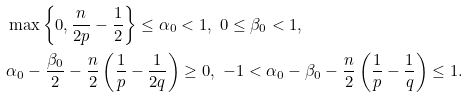Convert formula to latex. <formula><loc_0><loc_0><loc_500><loc_500>& \max \left \{ 0 , \frac { n } { 2 p } - \frac { 1 } { 2 } \right \} \leq \alpha _ { 0 } < 1 , \ 0 \leq \beta _ { 0 } < 1 , \\ & \alpha _ { 0 } - \frac { \beta _ { 0 } } { 2 } - \frac { n } { 2 } \left ( \frac { 1 } { p } - \frac { 1 } { 2 q } \right ) \geq 0 , \ - 1 < \alpha _ { 0 } - \beta _ { 0 } - \frac { n } { 2 } \left ( \frac { 1 } { p } - \frac { 1 } { q } \right ) \leq 1 .</formula> 